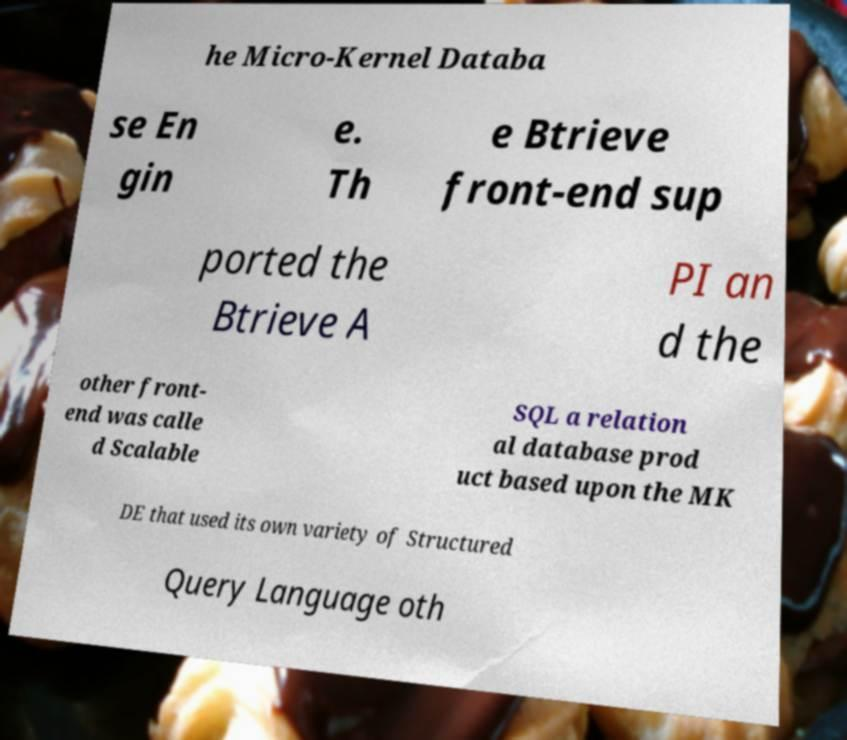Could you assist in decoding the text presented in this image and type it out clearly? he Micro-Kernel Databa se En gin e. Th e Btrieve front-end sup ported the Btrieve A PI an d the other front- end was calle d Scalable SQL a relation al database prod uct based upon the MK DE that used its own variety of Structured Query Language oth 